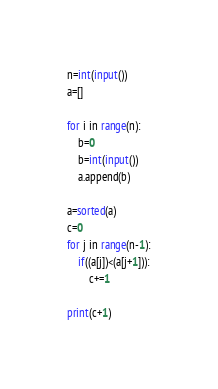Convert code to text. <code><loc_0><loc_0><loc_500><loc_500><_Python_>n=int(input())
a=[]

for i in range(n):
	b=0
	b=int(input())
	a.append(b)

a=sorted(a)
c=0
for j in range(n-1):
	if((a[j])<(a[j+1])):
		c+=1

print(c+1)</code> 